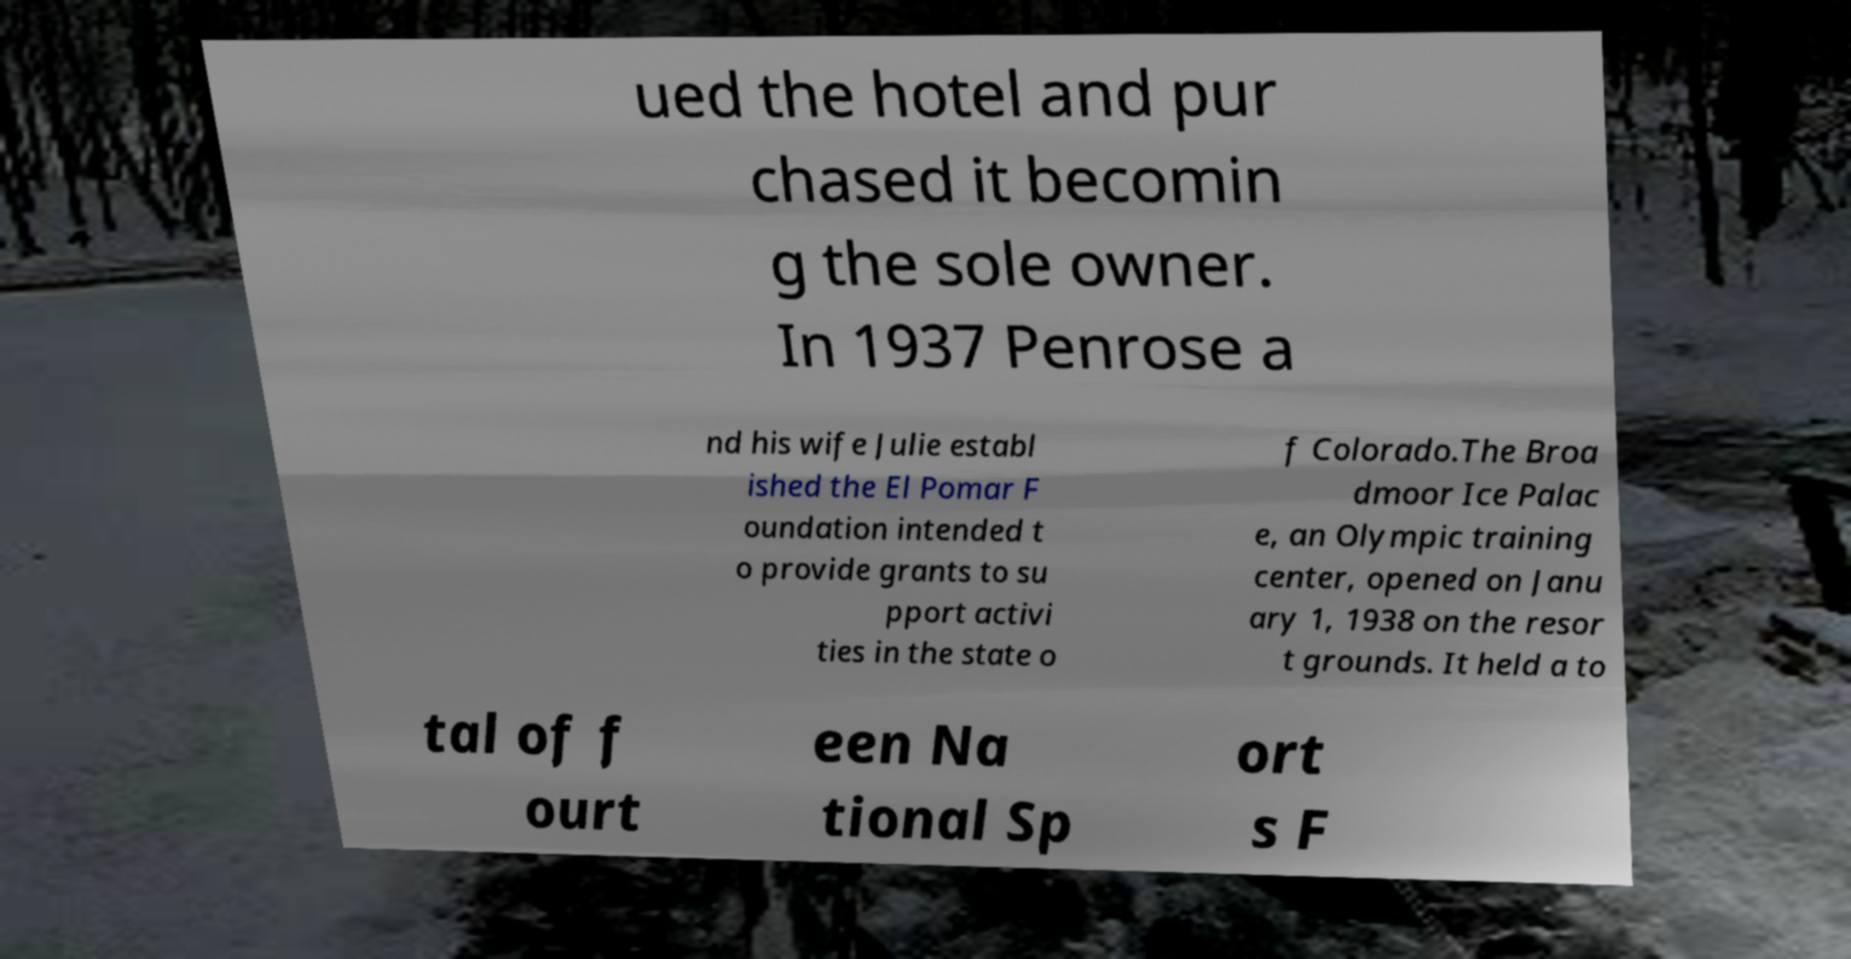Please read and relay the text visible in this image. What does it say? ued the hotel and pur chased it becomin g the sole owner. In 1937 Penrose a nd his wife Julie establ ished the El Pomar F oundation intended t o provide grants to su pport activi ties in the state o f Colorado.The Broa dmoor Ice Palac e, an Olympic training center, opened on Janu ary 1, 1938 on the resor t grounds. It held a to tal of f ourt een Na tional Sp ort s F 